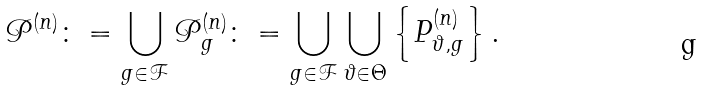Convert formula to latex. <formula><loc_0><loc_0><loc_500><loc_500>\mathcal { P } ^ { ( n ) } \colon = \bigcup _ { g \in \mathcal { F } } \mathcal { P } _ { g } ^ { ( n ) } \colon = \bigcup _ { g \in \mathcal { F } } \bigcup _ { \vartheta \in \Theta } \left \{ P ^ { ( n ) } _ { \vartheta , g } \right \} .</formula> 